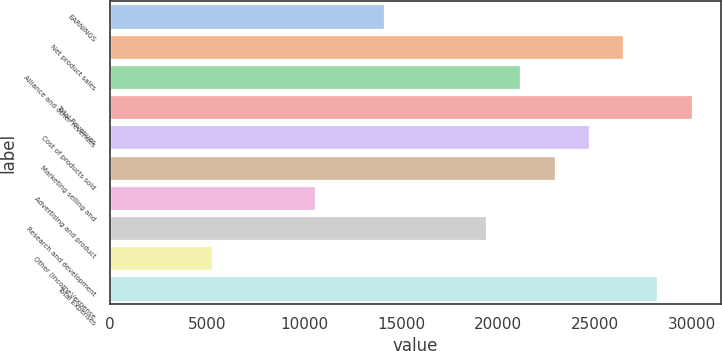Convert chart. <chart><loc_0><loc_0><loc_500><loc_500><bar_chart><fcel>EARNINGS<fcel>Net product sales<fcel>Alliance and other revenues<fcel>Total Revenues<fcel>Cost of products sold<fcel>Marketing selling and<fcel>Advertising and product<fcel>Research and development<fcel>Other (income)/expense<fcel>Total Expenses<nl><fcel>14097<fcel>26430.9<fcel>21144.9<fcel>29954.8<fcel>24668.9<fcel>22906.9<fcel>10573<fcel>19382.9<fcel>5287.1<fcel>28192.8<nl></chart> 